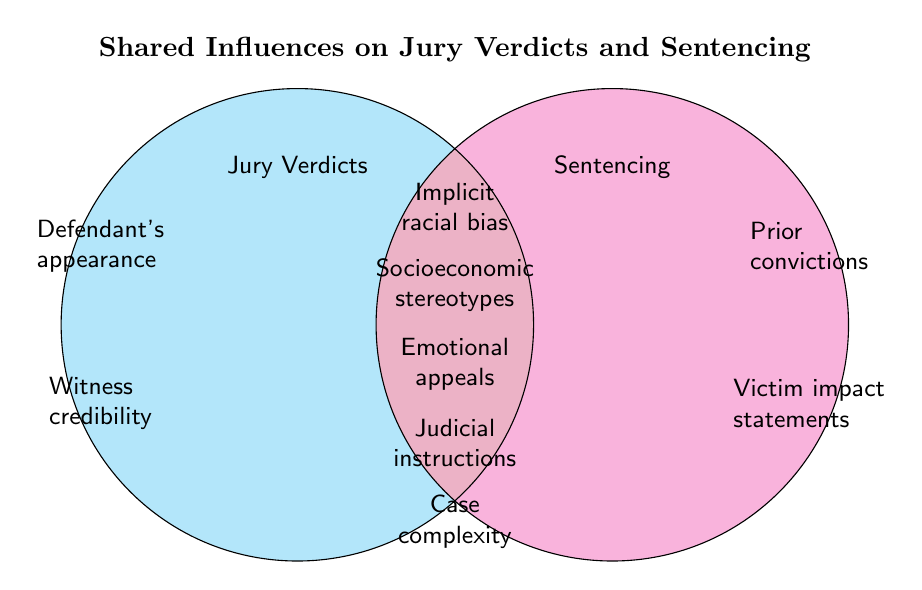What is the title of the Venn Diagram? The title is located at the top of the figure and provides a summary of what the diagram represents. The title is "Shared Influences on Jury Verdicts and Sentencing".
Answer: Shared Influences on Jury Verdicts and Sentencing Which influence is only related to Jury Verdicts? The influences only related to Jury Verdicts are positioned in the left circle. They are "Defendant's appearance" and "Witness credibility".
Answer: Defendant's appearance, Witness credibility Which influences are shared between Jury Verdicts and Sentencing? The shared influences are located in the overlapping area of the two circles. These are "Implicit racial bias", "Socioeconomic stereotypes", "Emotional appeals", "Judicial instructions", and "Case complexity".
Answer: Implicit racial bias, Socioeconomic stereotypes, Emotional appeals, Judicial instructions, Case complexity Identify all influences that are related to Sentencing. Influences related to Sentencing are in the right circle and the overlapping area. They include "Prior convictions", "Victim impact statements", "Implicit racial bias", "Socioeconomic stereotypes", "Emotional appeals", "Judicial instructions", and "Case complexity".
Answer: Prior convictions, Victim impact statements, Implicit racial bias, Socioeconomic stereotypes, Emotional appeals, Judicial instructions, Case complexity How many total influences are listed in the Venn Diagram? Count all distinct influences in both circles including the overlapping area. There are 9 influences in total.
Answer: 9 Which influences affect both Jury Verdicts and Sentencing but are not specific to only one? Influences in the overlapping area are shared, meaning they affect both Jury Verdicts and Sentencing and are not specific to only one. These influences are: "Implicit racial bias", "Socioeconomic stereotypes", "Emotional appeals", "Judicial instructions", and "Case complexity".
Answer: Implicit racial bias, Socioeconomic stereotypes, Emotional appeals, Judicial instructions, Case complexity How many influences are exclusive to Sentencing? Count the influences only in the right circle that do not overlap. These are "Prior convictions" and "Victim impact statements".
Answer: 2 Compare the number of influences exclusive to Jury Verdicts versus Sentencing. Which category has more exclusive influences? Count the exclusive influences in each circle. Jury Verdicts have 2 exclusive influences, and Sentencing also has 2 exclusive influences. Both categories have the same number.
Answer: Equal 